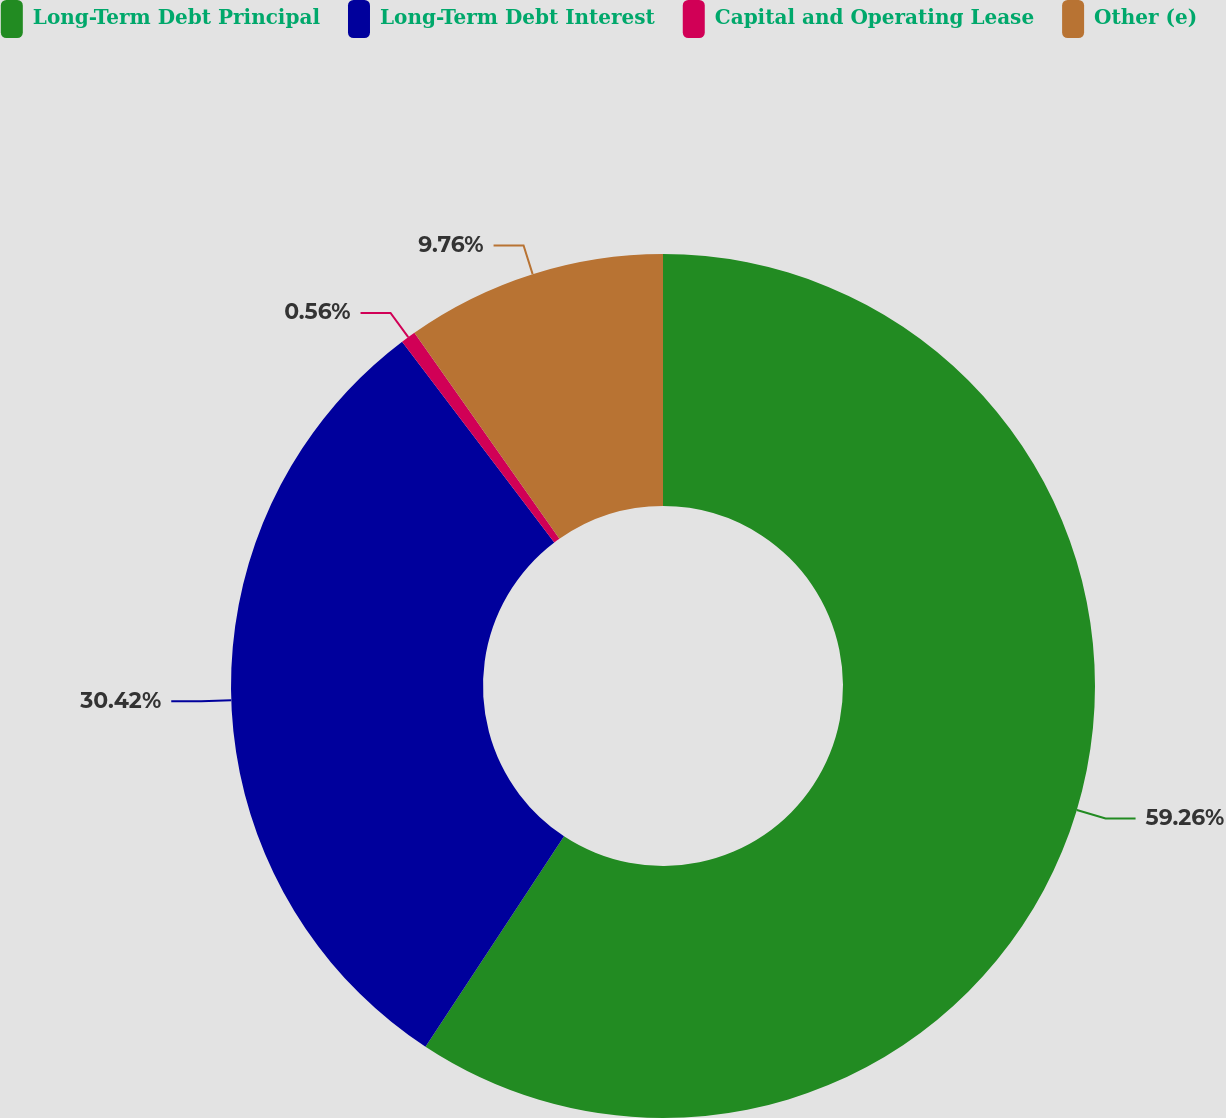Convert chart. <chart><loc_0><loc_0><loc_500><loc_500><pie_chart><fcel>Long-Term Debt Principal<fcel>Long-Term Debt Interest<fcel>Capital and Operating Lease<fcel>Other (e)<nl><fcel>59.27%<fcel>30.42%<fcel>0.56%<fcel>9.76%<nl></chart> 